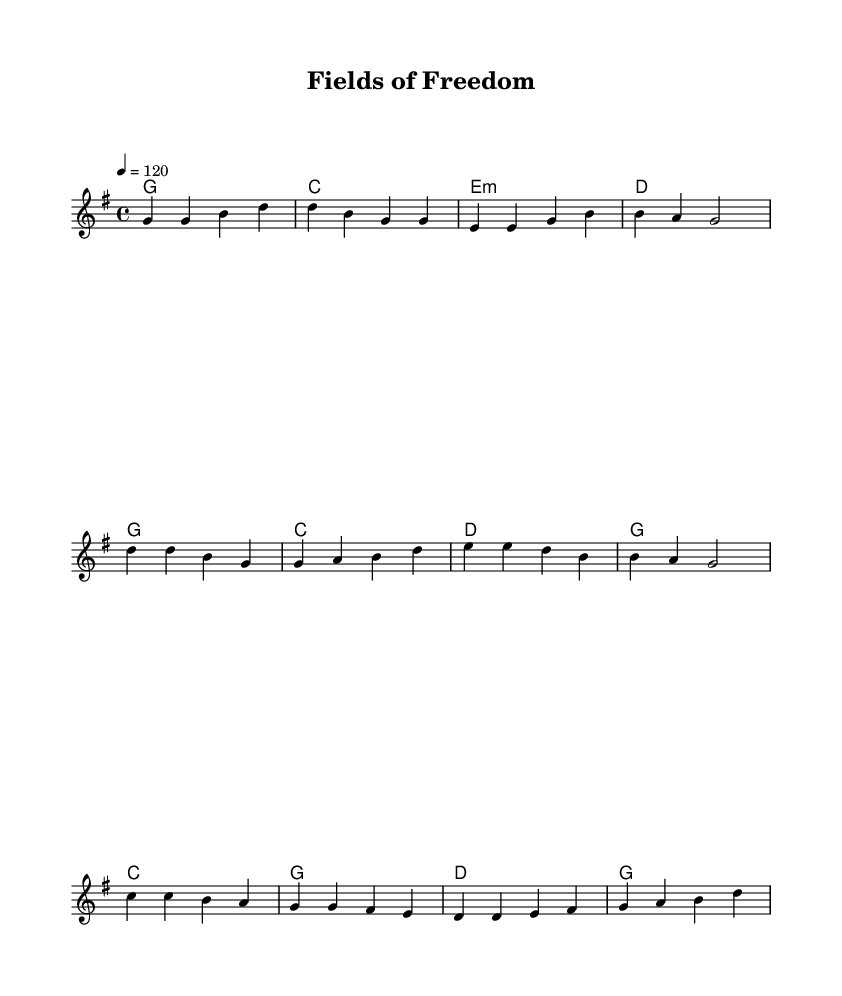What is the key signature of this music? The key signature is G major, which has one sharp (F#). You can tell this by looking at the key indication at the beginning of the staff.
Answer: G major What is the time signature of the music? The time signature is 4/4, as indicated by the "4/4" shown to the left of the clef. This means there are four beats in each measure and the quarter note gets one beat.
Answer: 4/4 What is the tempo marking of the piece? The tempo marking is 4 = 120. This indicates that the piece should be played at a speed of 120 beats per minute, which means there are 120 quarter note beats in one minute.
Answer: 120 How many measures are in the verse? The verse consists of four measures. By counting the notated bar lines in the section indicated as the Verse, we can see there are four measures.
Answer: 4 What is the predominant theme of the lyrics? The predominant theme of the lyrics is leaving the corporate world for a simpler life, as reflected in phrases that mention trading a suit for overalls and seeking freedom from city life.
Answer: Simpler life What do the lyrics in the chorus emphasize? The lyrics in the chorus emphasize the idea of freedom and escape, specifically expressing leaving behind a life of "rat races" for "fields of freedom". This theme is central to the country rock genre, which often celebrates rural life and personal simplicity.
Answer: Freedom What type of instrumentation is likely used in this genre? The instrumentation likely includes acoustic guitars, electric guitars, bass guitar, and drums. Country Rock typically combines these elements to create a sound that is both melodic and rhythmically engaging.
Answer: Acoustic and electric guitars 